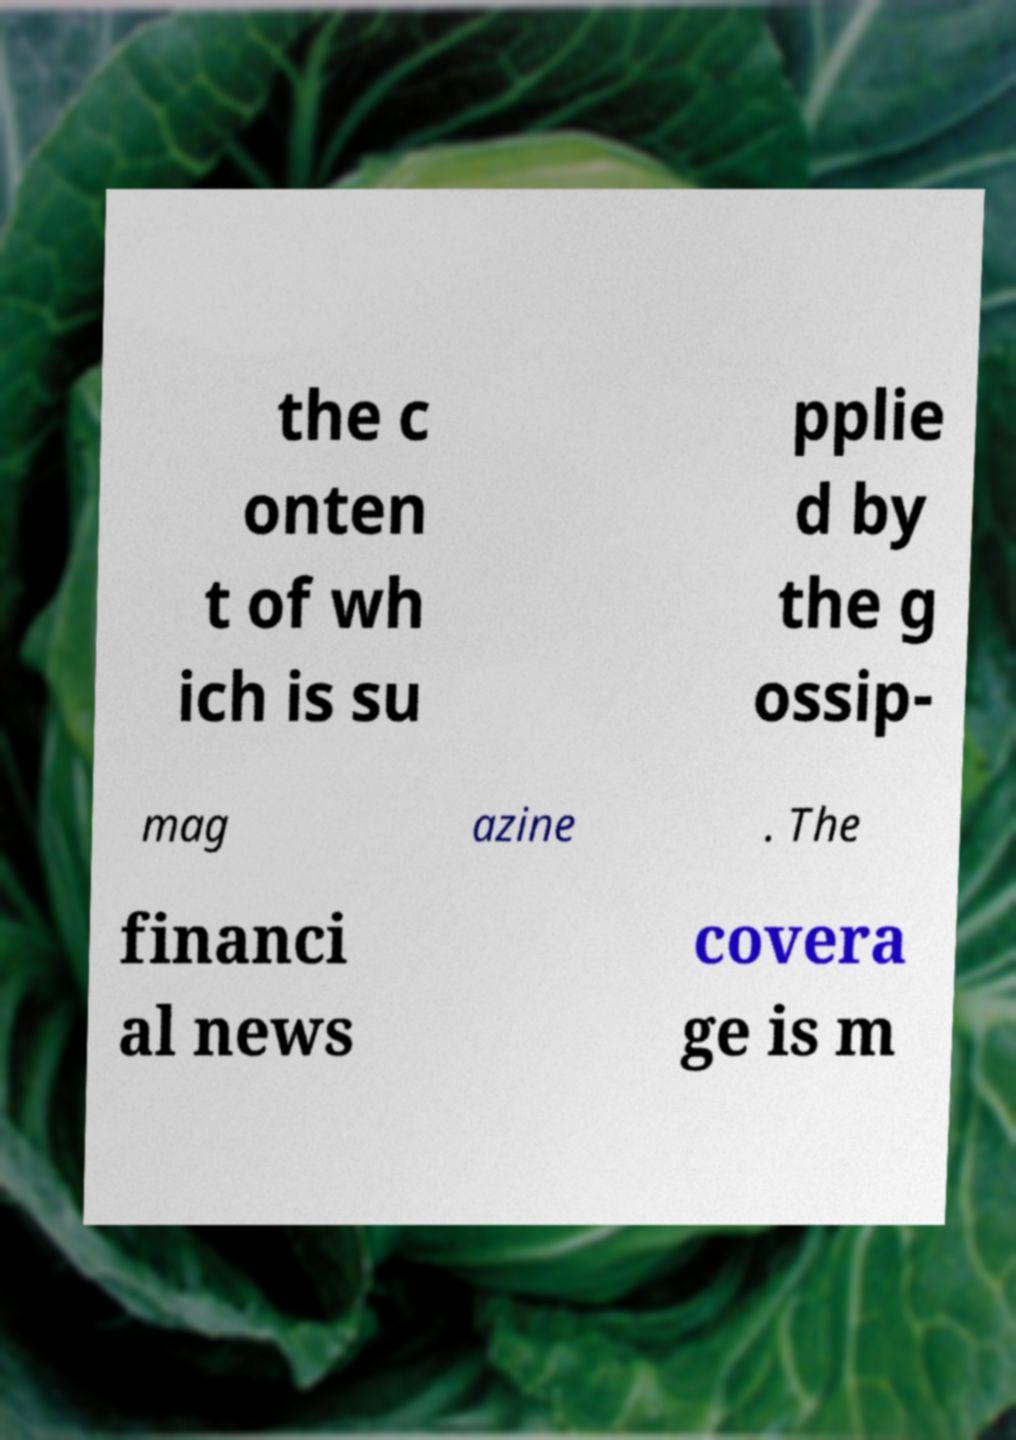Could you assist in decoding the text presented in this image and type it out clearly? the c onten t of wh ich is su pplie d by the g ossip- mag azine . The financi al news covera ge is m 